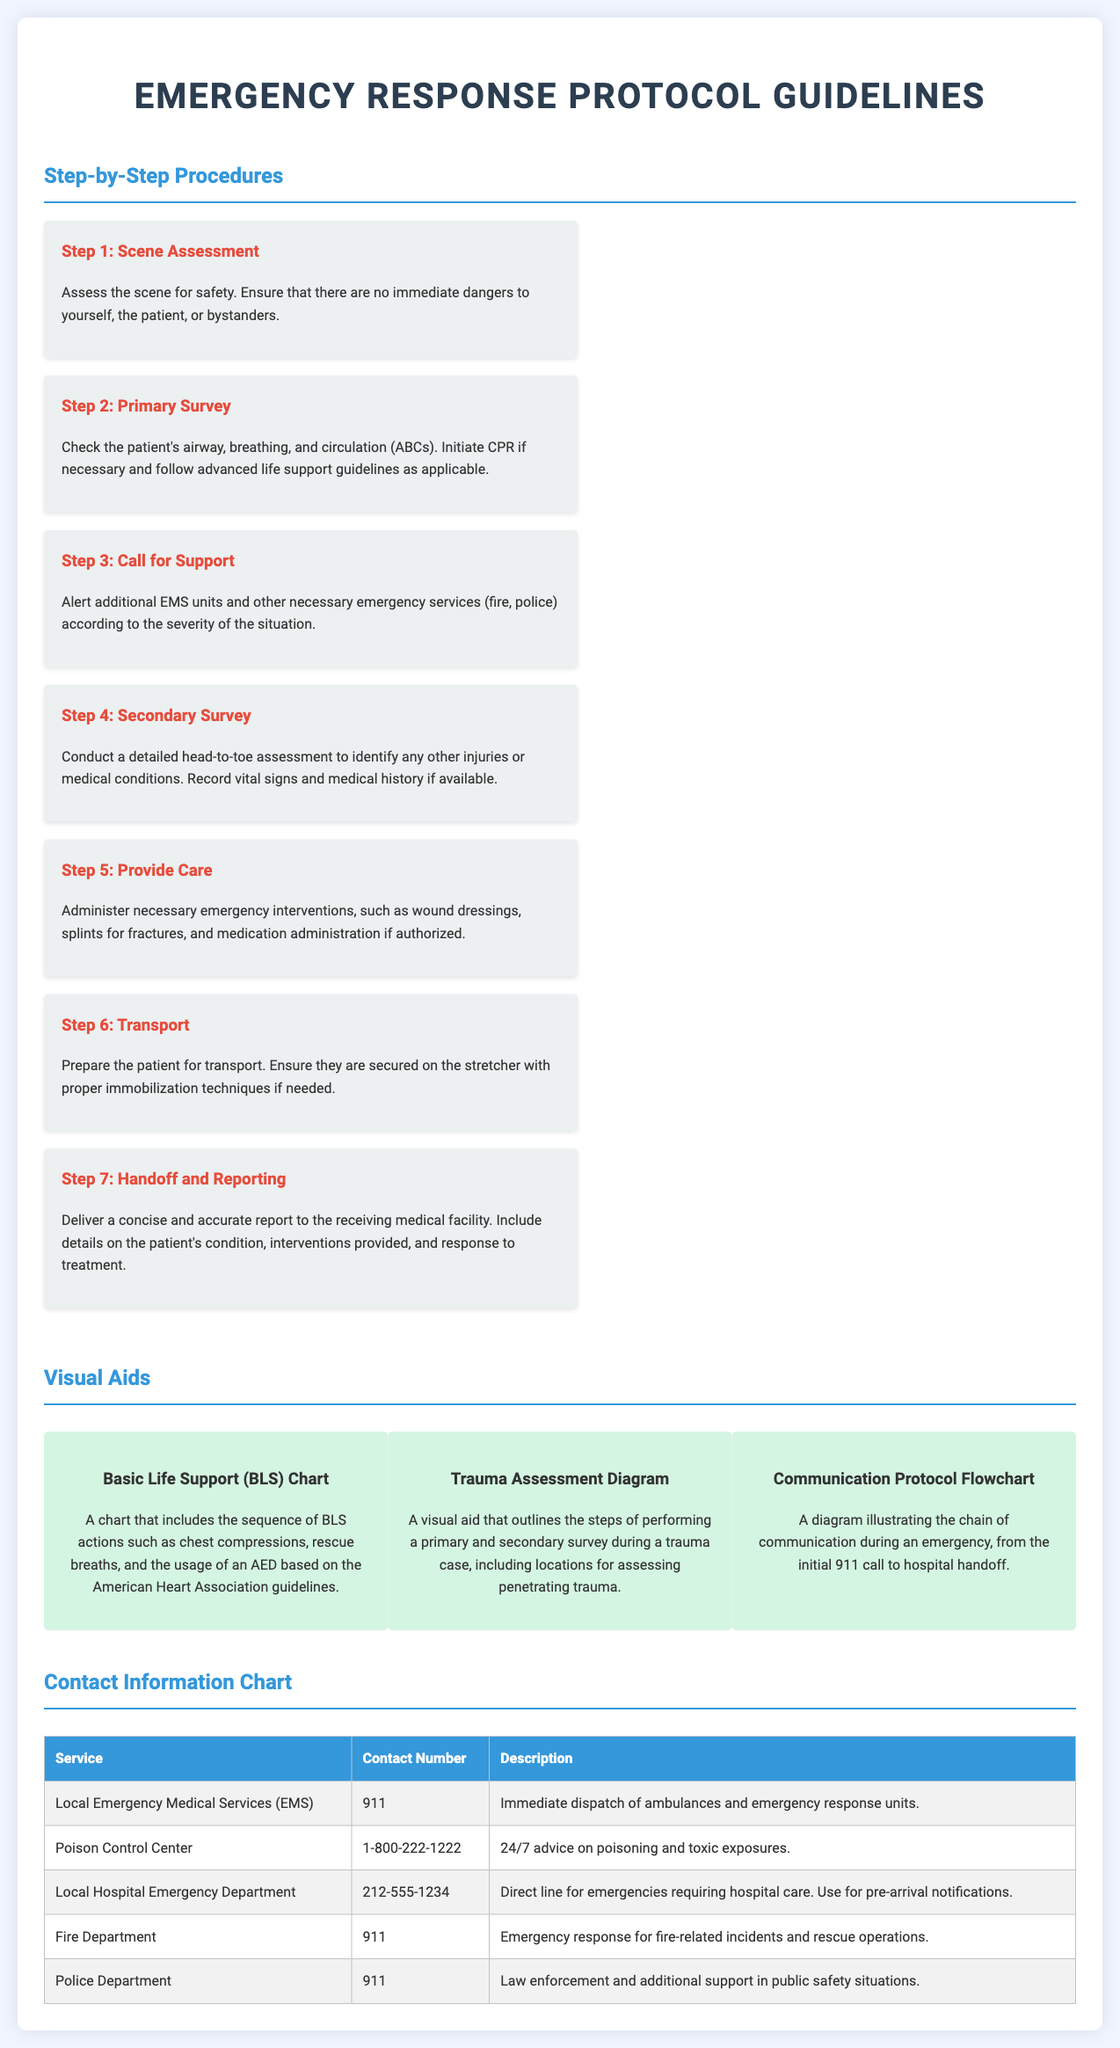What is the first step in the procedures? The document lists "Scene Assessment" as the first step in the procedures.
Answer: Scene Assessment How many steps are outlined in the procedures? The document presents a total of seven steps in the procedures.
Answer: 7 What is the contact number for the Poison Control Center? The document provides the specific contact number for the Poison Control Center as 1-800-222-1222.
Answer: 1-800-222-1222 What visual aid outlines the steps of a primary and secondary survey? The document mentions the "Trauma Assessment Diagram" as the visual aid that covers the steps of a primary and secondary survey.
Answer: Trauma Assessment Diagram What is the purpose of the Emergency Medical Services contact number? The document states that the local EMS contact number is for immediate dispatch of ambulances and emergency response units.
Answer: Immediate dispatch What action should be taken during the Primary Survey step? The document indicates that the action during the Primary Survey is to check the patient's airway, breathing, and circulation.
Answer: Check ABCs What is the last step in the procedures? The document outlines "Handoff and Reporting" as the final step in the procedures.
Answer: Handoff and Reporting Which visual aid details Communication Protocol? The document specifies the "Communication Protocol Flowchart" as the visual aid that illustrates the chain of communication during an emergency.
Answer: Communication Protocol Flowchart 